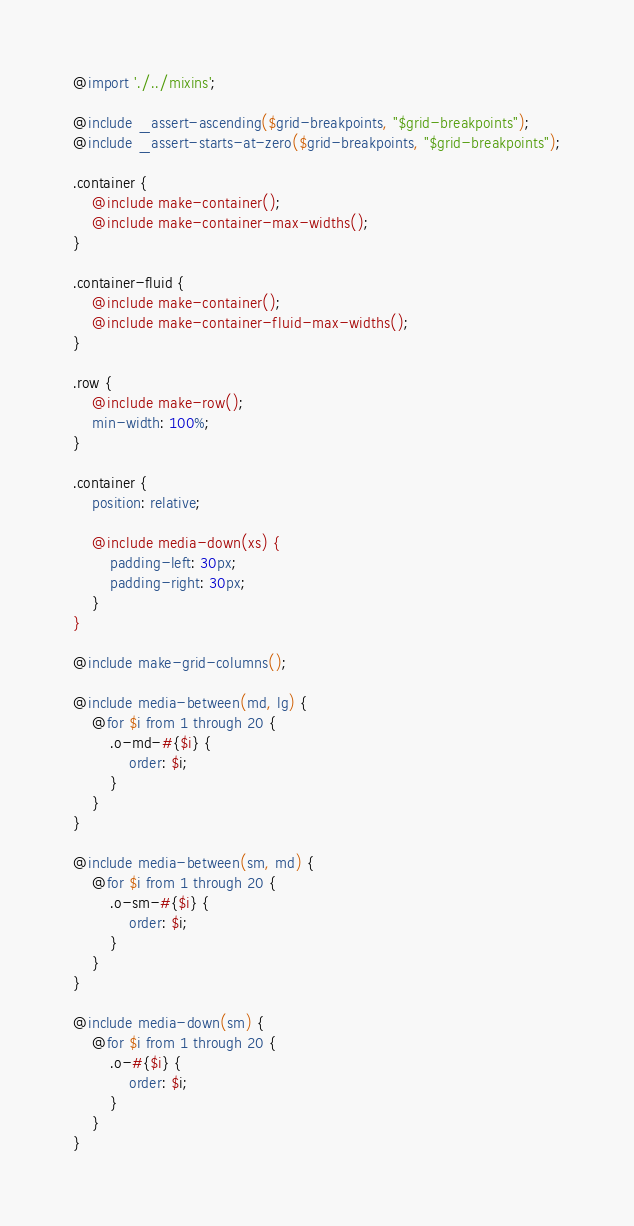<code> <loc_0><loc_0><loc_500><loc_500><_CSS_>@import './../mixins';

@include _assert-ascending($grid-breakpoints, "$grid-breakpoints");
@include _assert-starts-at-zero($grid-breakpoints, "$grid-breakpoints");

.container {
	@include make-container();
	@include make-container-max-widths();
}

.container-fluid {
	@include make-container();
	@include make-container-fluid-max-widths();
}

.row {
	@include make-row();
	min-width: 100%;
}

.container {
	position: relative;

	@include media-down(xs) {
		padding-left: 30px;
		padding-right: 30px;
	}
}

@include make-grid-columns();

@include media-between(md, lg) {
	@for $i from 1 through 20 {
		.o-md-#{$i} {
			order: $i;
		}
	}
}

@include media-between(sm, md) {
	@for $i from 1 through 20 {
		.o-sm-#{$i} {
			order: $i;
		}
	}
}

@include media-down(sm) {
	@for $i from 1 through 20 {
		.o-#{$i} {
			order: $i;
		}
	}
}
</code> 